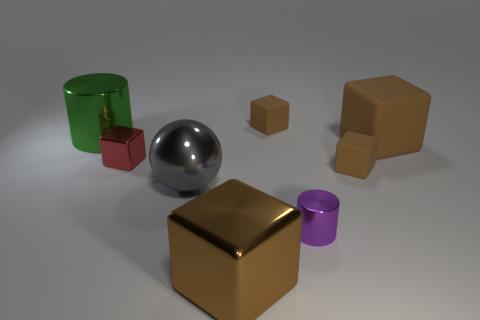There is a metal thing that is the same color as the big rubber object; what is its size?
Make the answer very short. Large. What is the shape of the large brown metallic object?
Give a very brief answer. Cube. The big object that is left of the large metallic sphere that is to the left of the tiny shiny cylinder is what shape?
Your response must be concise. Cylinder. Does the brown object behind the big matte thing have the same material as the small purple cylinder?
Ensure brevity in your answer.  No. How many red objects are either metal cubes or large rubber blocks?
Offer a terse response. 1. Is there a tiny block of the same color as the large matte cube?
Offer a terse response. Yes. Are there any large cyan cylinders made of the same material as the red block?
Provide a short and direct response. No. The large thing that is both behind the small red metal cube and to the left of the tiny cylinder has what shape?
Provide a short and direct response. Cylinder. What number of large objects are brown rubber cubes or green rubber things?
Offer a very short reply. 1. What is the material of the green thing?
Your answer should be compact. Metal. 